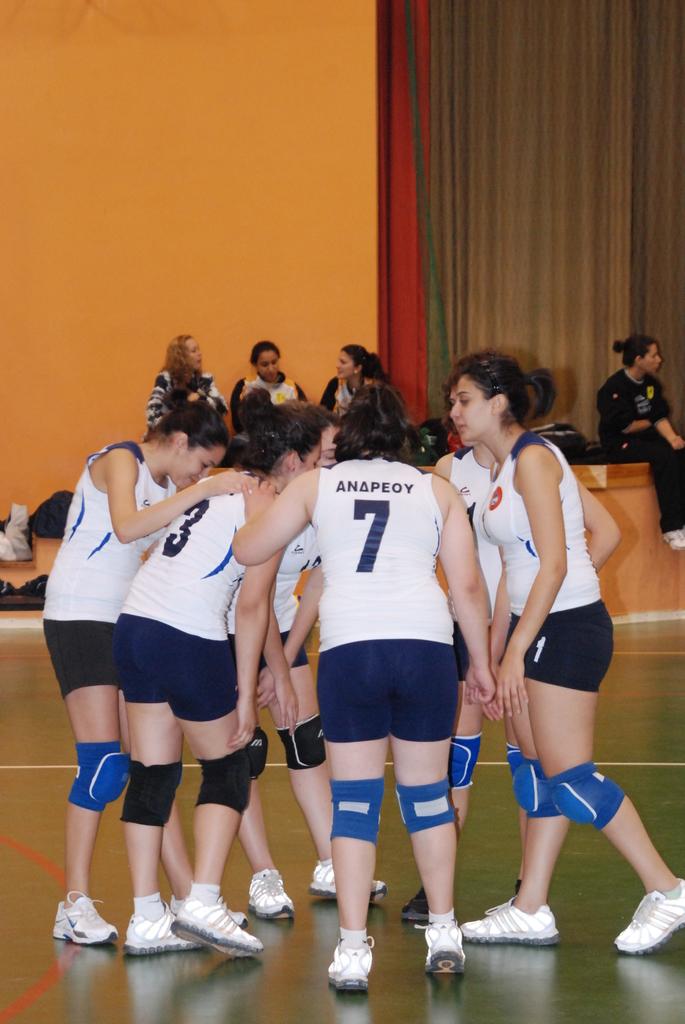What are the numbers on the back of the girls shirts?
Provide a short and direct response. 7. What is the name of number 7?
Keep it short and to the point. Anapeoy. 